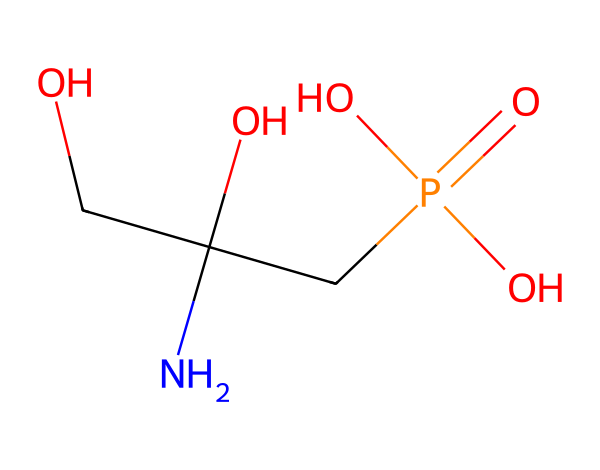What is the molecular formula of glyphosate? To find the molecular formula, we count the number of each type of atom in the SMILES representation. The breakdown shows that there are 3 carbons, 8 hydrogens, 1 nitrogen, and 5 oxygens, leading to the formula C3H8N5O.
Answer: C3H8N5O How many oxygen atoms are present in glyphosate? By analyzing the SMILES representation, we can see that there are 5 oxygen atoms linked in various functional groups.
Answer: 5 What functional groups are present in glyphosate? The SMILES indicates the presence of a phosphate group (from the P=O and O) and hydroxyl groups (from the OH present in OCC(O)). These functional groups indicate its role as a herbicide.
Answer: phosphate and hydroxyl What is the total number of bonds in glyphosate? Looking at the SMILES structure, we can visualize the connections: each bond between atoms is counted, leading to a total of 8 bonds connecting all atoms in the structure.
Answer: 8 Does glyphosate contain a nitrogen atom? The SMILES clearly shows a nitrogen atom (N), which is crucial for the composition, indicating it functions differently from simple organic compounds.
Answer: yes How does the presence of phosphorus affect glyphosate's function as a herbicide? The presence of phosphorus (from the P) indicates glyphosate's effectiveness as a herbicide, as phosphorus can help disrupt metabolic processes in plants, especially in the shikimic acid pathway.
Answer: metabolic disruption What makes glyphosate a systematic herbicide? Glyphosate is considered systemic due to its ability to be absorbed through plant foliage and translocated, which is indicated by its chemical structure containing nitrogen and phosphorus, enhancing its mobility within plants.
Answer: systemic absorption 